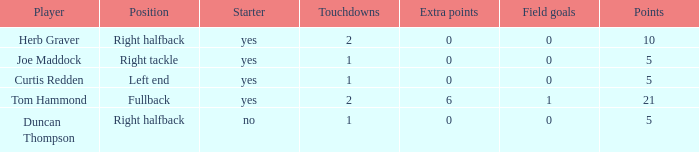Name the fewest touchdowns 1.0. 